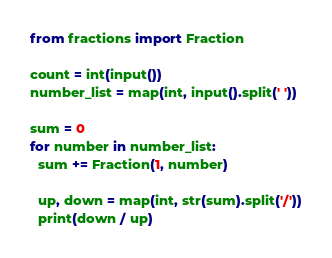<code> <loc_0><loc_0><loc_500><loc_500><_Python_>from fractions import Fraction

count = int(input())
number_list = map(int, input().split(' '))

sum = 0
for number in number_list:
  sum += Fraction(1, number)

  up, down = map(int, str(sum).split('/'))
  print(down / up)    </code> 